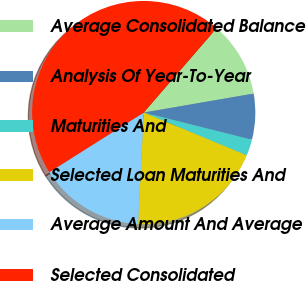Convert chart. <chart><loc_0><loc_0><loc_500><loc_500><pie_chart><fcel>Average Consolidated Balance<fcel>Analysis Of Year-To-Year<fcel>Maturities And<fcel>Selected Loan Maturities And<fcel>Average Amount And Average<fcel>Selected Consolidated<nl><fcel>10.94%<fcel>6.64%<fcel>2.35%<fcel>19.53%<fcel>15.23%<fcel>45.3%<nl></chart> 